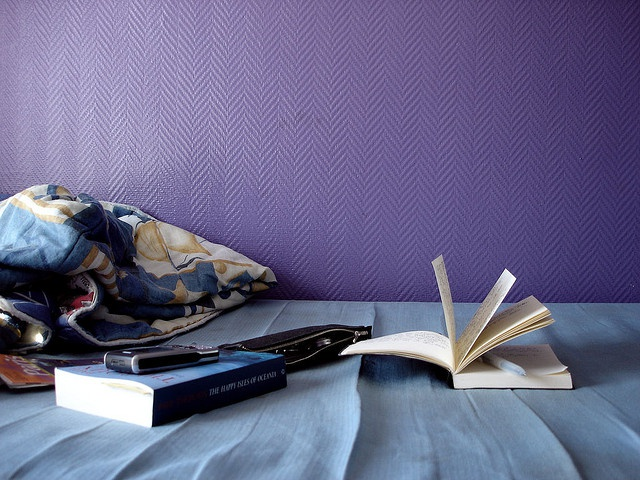Describe the objects in this image and their specific colors. I can see bed in gray and black tones, book in gray, lightgray, darkgray, and tan tones, book in gray, black, white, and darkgray tones, and cell phone in gray, black, and navy tones in this image. 